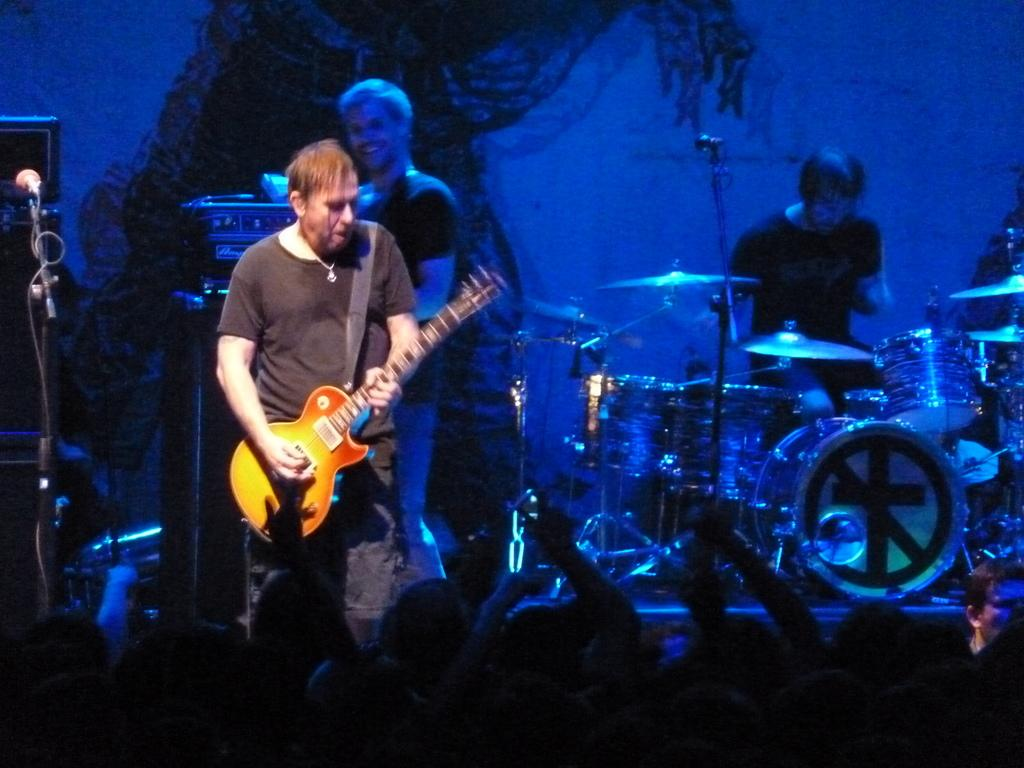How many people are standing in the image? There are two persons standing in the image. What is one person holding? One person is holding a guitar. What equipment is present for amplifying sound? There is a microphone with a stand. What is the position of one person in the image? One person is sitting. What other musical instrument can be seen in the image? There is a musical instrument, but it is not specified which one. Can you describe the audience in the image? There are audience members present in the image. What type of insurance policy is being discussed by the person holding the guitar? There is no mention of insurance or any discussion in the image, as it focuses on people and musical instruments. 